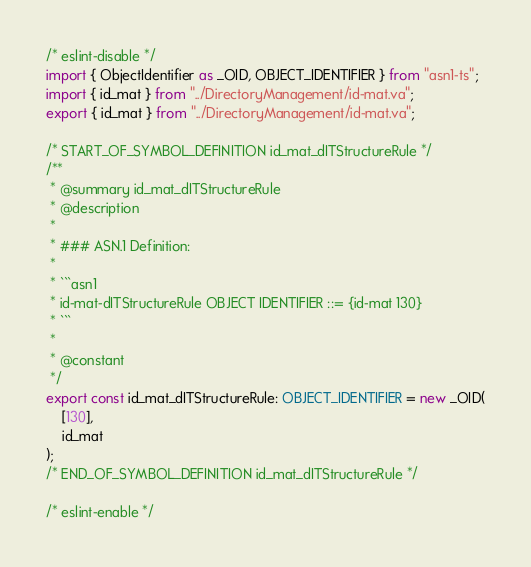Convert code to text. <code><loc_0><loc_0><loc_500><loc_500><_TypeScript_>/* eslint-disable */
import { ObjectIdentifier as _OID, OBJECT_IDENTIFIER } from "asn1-ts";
import { id_mat } from "../DirectoryManagement/id-mat.va";
export { id_mat } from "../DirectoryManagement/id-mat.va";

/* START_OF_SYMBOL_DEFINITION id_mat_dITStructureRule */
/**
 * @summary id_mat_dITStructureRule
 * @description
 *
 * ### ASN.1 Definition:
 *
 * ```asn1
 * id-mat-dITStructureRule OBJECT IDENTIFIER ::= {id-mat 130}
 * ```
 *
 * @constant
 */
export const id_mat_dITStructureRule: OBJECT_IDENTIFIER = new _OID(
    [130],
    id_mat
);
/* END_OF_SYMBOL_DEFINITION id_mat_dITStructureRule */

/* eslint-enable */
</code> 